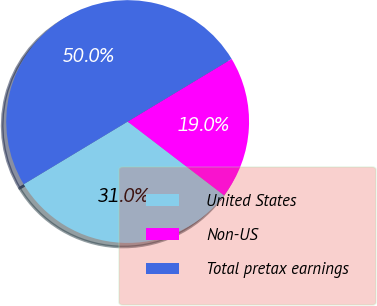Convert chart to OTSL. <chart><loc_0><loc_0><loc_500><loc_500><pie_chart><fcel>United States<fcel>Non-US<fcel>Total pretax earnings<nl><fcel>30.97%<fcel>19.03%<fcel>50.0%<nl></chart> 